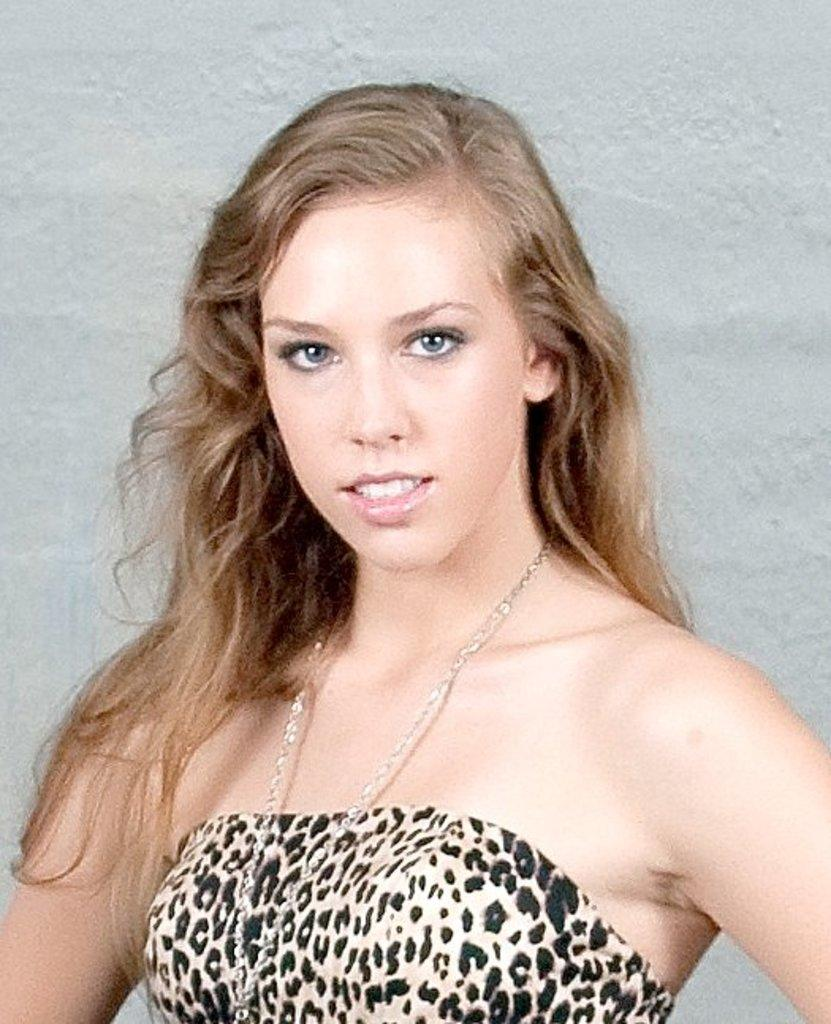Who is present in the image? There is a woman in the image. What is the price of the tub in the image? There is no tub present in the image, so it is not possible to determine its price. 